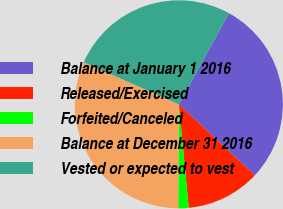<chart> <loc_0><loc_0><loc_500><loc_500><pie_chart><fcel>Balance at January 1 2016<fcel>Released/Exercised<fcel>Forfeited/Canceled<fcel>Balance at December 31 2016<fcel>Vested or expected to vest<nl><fcel>28.95%<fcel>11.53%<fcel>1.61%<fcel>31.53%<fcel>26.37%<nl></chart> 